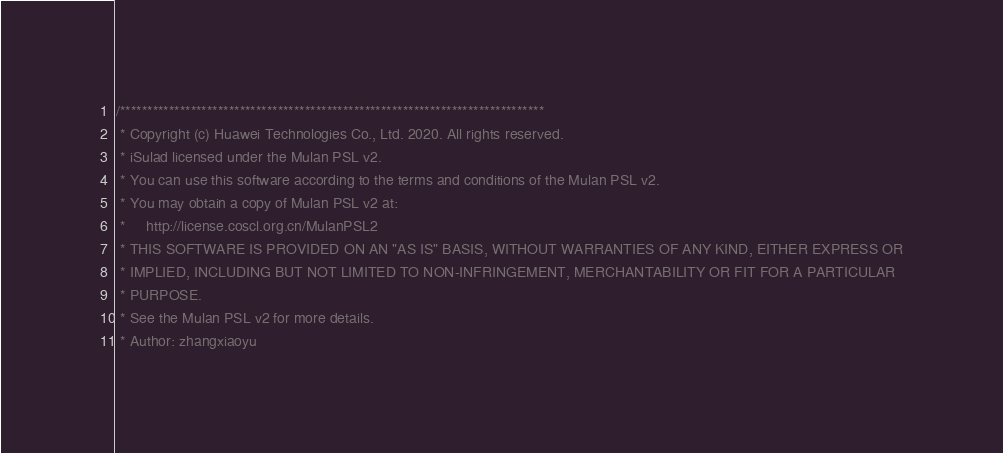Convert code to text. <code><loc_0><loc_0><loc_500><loc_500><_C_>/******************************************************************************
 * Copyright (c) Huawei Technologies Co., Ltd. 2020. All rights reserved.
 * iSulad licensed under the Mulan PSL v2.
 * You can use this software according to the terms and conditions of the Mulan PSL v2.
 * You may obtain a copy of Mulan PSL v2 at:
 *     http://license.coscl.org.cn/MulanPSL2
 * THIS SOFTWARE IS PROVIDED ON AN "AS IS" BASIS, WITHOUT WARRANTIES OF ANY KIND, EITHER EXPRESS OR
 * IMPLIED, INCLUDING BUT NOT LIMITED TO NON-INFRINGEMENT, MERCHANTABILITY OR FIT FOR A PARTICULAR
 * PURPOSE.
 * See the Mulan PSL v2 for more details.
 * Author: zhangxiaoyu</code> 